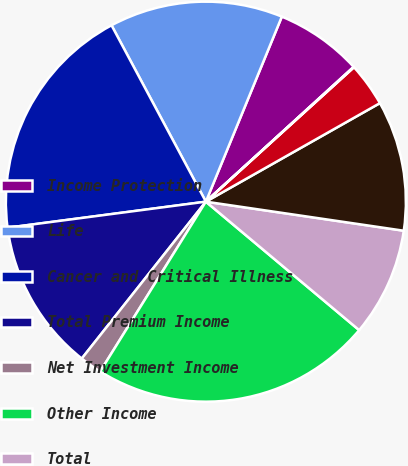Convert chart to OTSL. <chart><loc_0><loc_0><loc_500><loc_500><pie_chart><fcel>Income Protection<fcel>Life<fcel>Cancer and Critical Illness<fcel>Total Premium Income<fcel>Net Investment Income<fcel>Other Income<fcel>Total<fcel>Benefits and Change in<fcel>Commissions<fcel>Deferral of Policy Acquisition<nl><fcel>7.03%<fcel>14.02%<fcel>19.26%<fcel>12.27%<fcel>1.79%<fcel>22.76%<fcel>8.78%<fcel>10.52%<fcel>3.53%<fcel>0.04%<nl></chart> 